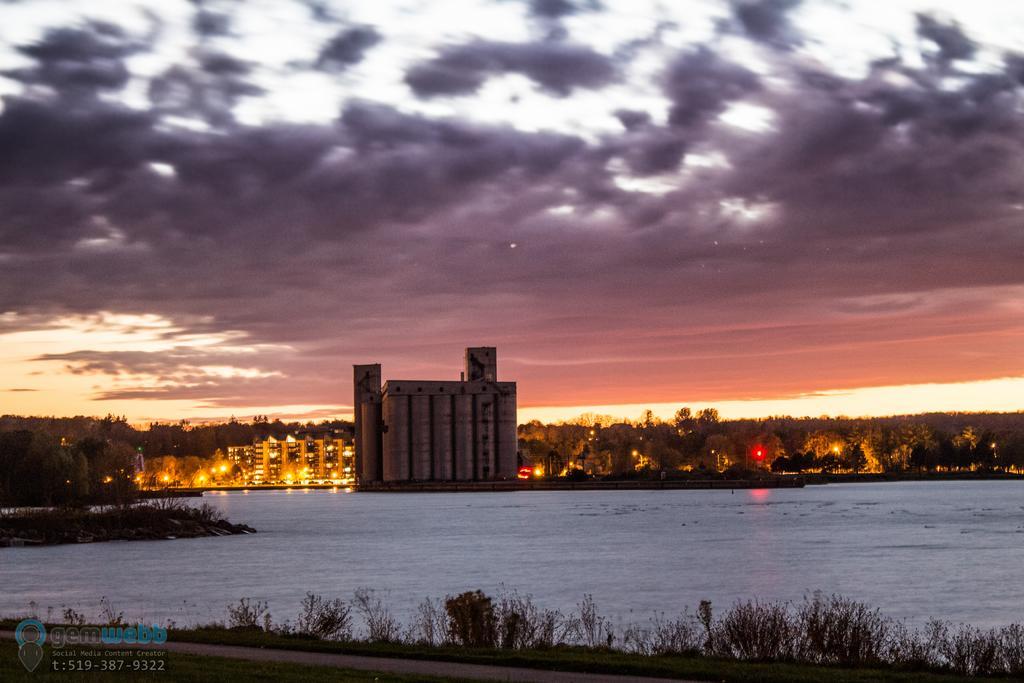Could you give a brief overview of what you see in this image? In the center of the image we can see buildings, trees, lights. At the bottom of the image we can see water, plants, ground. At the top of the image clouds are present in the sky. 